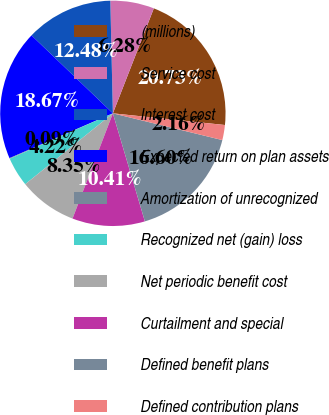<chart> <loc_0><loc_0><loc_500><loc_500><pie_chart><fcel>(millions)<fcel>Service cost<fcel>Interest cost<fcel>Expected return on plan assets<fcel>Amortization of unrecognized<fcel>Recognized net (gain) loss<fcel>Net periodic benefit cost<fcel>Curtailment and special<fcel>Defined benefit plans<fcel>Defined contribution plans<nl><fcel>20.73%<fcel>6.28%<fcel>12.48%<fcel>18.67%<fcel>0.09%<fcel>4.22%<fcel>8.35%<fcel>10.41%<fcel>16.6%<fcel>2.16%<nl></chart> 